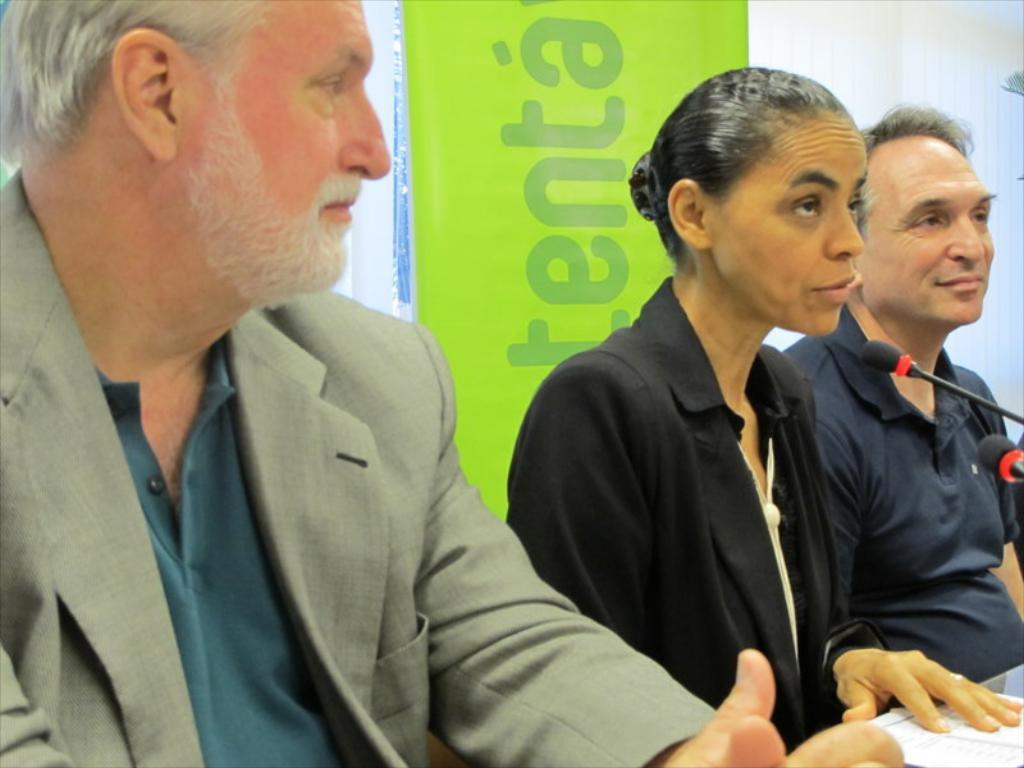How many people are sitting in the image? There are three persons sitting in the image. What is on the table in front of the people? There are papers and microphones on the table. What can be seen at the back of the scene? There is a hoarding at the back of the scene. What is written on the hoarding? There is text on the hoarding. Can you see any bees buzzing around the microphones in the image? There are no bees present in the image. What company is hosting the event depicted in the image? The provided facts do not mention any specific company or event, so it cannot be determined from the image. 